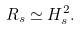<formula> <loc_0><loc_0><loc_500><loc_500>R _ { s } \simeq H _ { s } ^ { 2 } .</formula> 